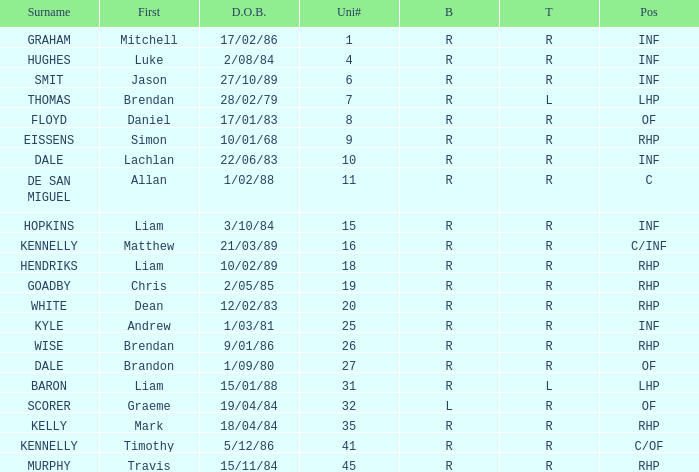Which player has a last name of baron? R. 